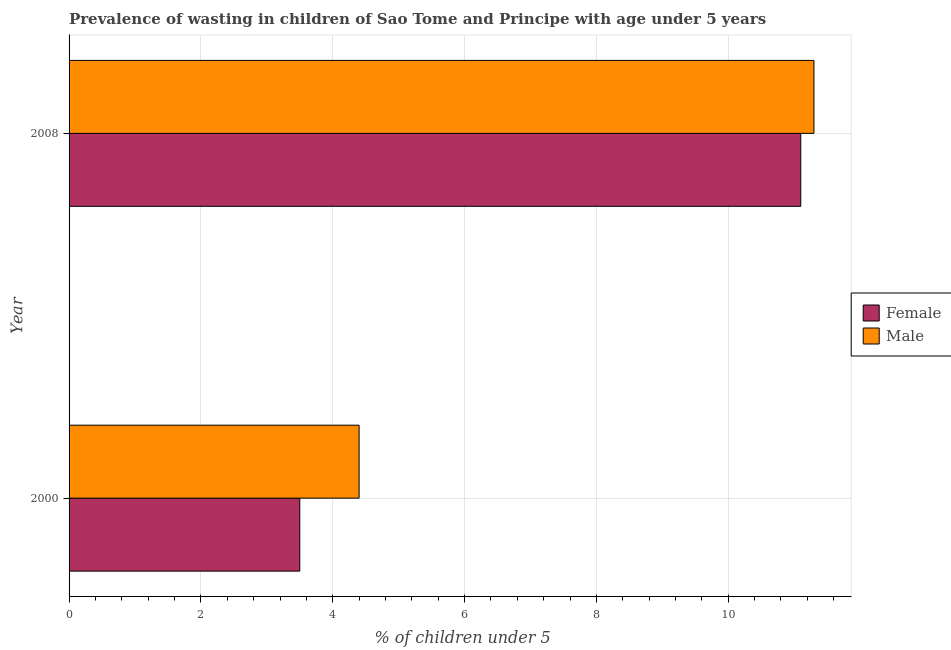How many different coloured bars are there?
Offer a very short reply. 2. Are the number of bars per tick equal to the number of legend labels?
Offer a very short reply. Yes. How many bars are there on the 1st tick from the bottom?
Your answer should be compact. 2. What is the label of the 1st group of bars from the top?
Provide a short and direct response. 2008. In how many cases, is the number of bars for a given year not equal to the number of legend labels?
Offer a terse response. 0. What is the percentage of undernourished female children in 2000?
Make the answer very short. 3.5. Across all years, what is the maximum percentage of undernourished female children?
Give a very brief answer. 11.1. In which year was the percentage of undernourished male children maximum?
Provide a succinct answer. 2008. What is the total percentage of undernourished female children in the graph?
Provide a short and direct response. 14.6. What is the difference between the percentage of undernourished male children in 2000 and that in 2008?
Offer a very short reply. -6.9. What is the difference between the percentage of undernourished male children in 2000 and the percentage of undernourished female children in 2008?
Your answer should be compact. -6.7. What is the average percentage of undernourished male children per year?
Your answer should be very brief. 7.85. In the year 2008, what is the difference between the percentage of undernourished female children and percentage of undernourished male children?
Give a very brief answer. -0.2. What is the ratio of the percentage of undernourished female children in 2000 to that in 2008?
Provide a succinct answer. 0.32. Is the difference between the percentage of undernourished female children in 2000 and 2008 greater than the difference between the percentage of undernourished male children in 2000 and 2008?
Make the answer very short. No. What does the 1st bar from the top in 2008 represents?
Keep it short and to the point. Male. Does the graph contain any zero values?
Give a very brief answer. No. Where does the legend appear in the graph?
Give a very brief answer. Center right. How many legend labels are there?
Your answer should be very brief. 2. What is the title of the graph?
Offer a very short reply. Prevalence of wasting in children of Sao Tome and Principe with age under 5 years. What is the label or title of the X-axis?
Offer a terse response.  % of children under 5. What is the label or title of the Y-axis?
Ensure brevity in your answer.  Year. What is the  % of children under 5 of Female in 2000?
Ensure brevity in your answer.  3.5. What is the  % of children under 5 of Male in 2000?
Your answer should be compact. 4.4. What is the  % of children under 5 in Female in 2008?
Your answer should be very brief. 11.1. What is the  % of children under 5 in Male in 2008?
Make the answer very short. 11.3. Across all years, what is the maximum  % of children under 5 in Female?
Ensure brevity in your answer.  11.1. Across all years, what is the maximum  % of children under 5 in Male?
Your answer should be compact. 11.3. Across all years, what is the minimum  % of children under 5 in Female?
Your response must be concise. 3.5. Across all years, what is the minimum  % of children under 5 in Male?
Your response must be concise. 4.4. What is the total  % of children under 5 of Female in the graph?
Your answer should be very brief. 14.6. What is the difference between the  % of children under 5 of Female in 2000 and that in 2008?
Offer a terse response. -7.6. What is the difference between the  % of children under 5 in Male in 2000 and that in 2008?
Make the answer very short. -6.9. What is the difference between the  % of children under 5 of Female in 2000 and the  % of children under 5 of Male in 2008?
Your answer should be compact. -7.8. What is the average  % of children under 5 in Female per year?
Offer a terse response. 7.3. What is the average  % of children under 5 in Male per year?
Your answer should be very brief. 7.85. In the year 2000, what is the difference between the  % of children under 5 in Female and  % of children under 5 in Male?
Provide a succinct answer. -0.9. In the year 2008, what is the difference between the  % of children under 5 in Female and  % of children under 5 in Male?
Keep it short and to the point. -0.2. What is the ratio of the  % of children under 5 in Female in 2000 to that in 2008?
Your response must be concise. 0.32. What is the ratio of the  % of children under 5 in Male in 2000 to that in 2008?
Make the answer very short. 0.39. What is the difference between the highest and the second highest  % of children under 5 in Male?
Your answer should be very brief. 6.9. What is the difference between the highest and the lowest  % of children under 5 of Female?
Offer a very short reply. 7.6. What is the difference between the highest and the lowest  % of children under 5 in Male?
Make the answer very short. 6.9. 